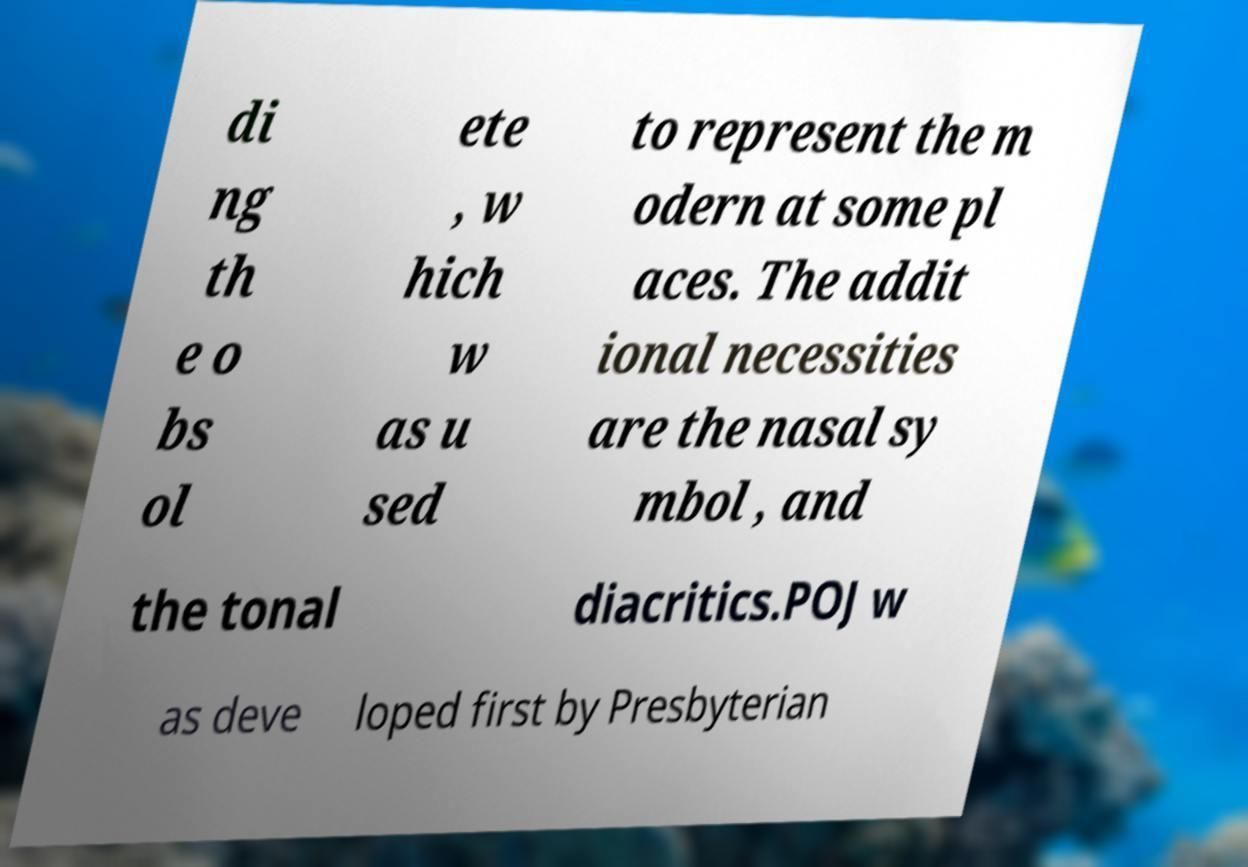For documentation purposes, I need the text within this image transcribed. Could you provide that? di ng th e o bs ol ete , w hich w as u sed to represent the m odern at some pl aces. The addit ional necessities are the nasal sy mbol , and the tonal diacritics.POJ w as deve loped first by Presbyterian 